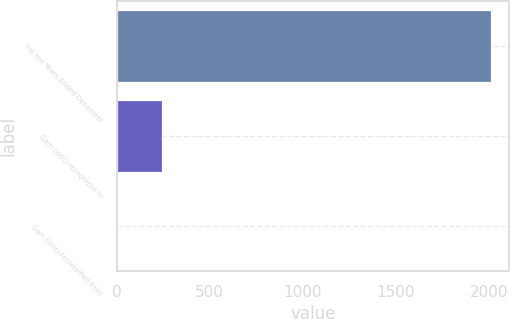Convert chart to OTSL. <chart><loc_0><loc_0><loc_500><loc_500><bar_chart><fcel>For the Years Ended December<fcel>Gain (loss) recognized in<fcel>Gain (loss) reclassified from<nl><fcel>2009<fcel>245<fcel>6<nl></chart> 